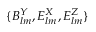<formula> <loc_0><loc_0><loc_500><loc_500>{ \{ B _ { l m } ^ { Y } , E _ { l m } ^ { X } , E _ { l m } ^ { Z } \} }</formula> 